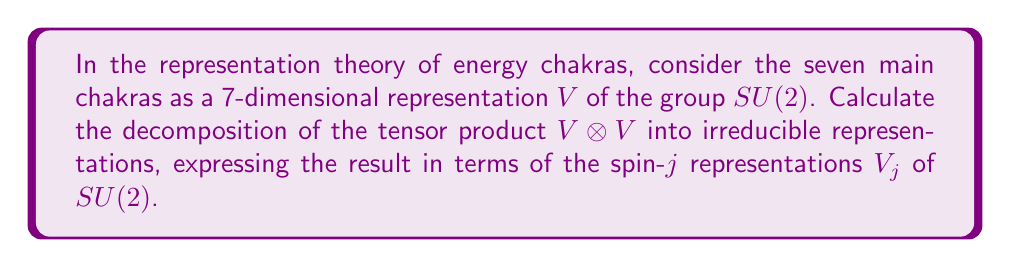Can you answer this question? To solve this problem, we'll follow these steps:

1) First, recall that the 7-dimensional representation $V$ of $SU(2)$ corresponds to the spin-3 representation $V_3$.

2) The general formula for decomposing the tensor product of two irreducible representations of $SU(2)$ is:

   $$V_j \otimes V_k \cong V_{|j-k|} \oplus V_{|j-k|+1} \oplus ... \oplus V_{j+k-1} \oplus V_{j+k}$$

3) In our case, $j = k = 3$, so we have:

   $$V_3 \otimes V_3 \cong V_{|3-3|} \oplus V_{|3-3|+1} \oplus ... \oplus V_{3+3-1} \oplus V_{3+3}$$

4) Simplifying:

   $$V_3 \otimes V_3 \cong V_0 \oplus V_1 \oplus V_2 \oplus V_3 \oplus V_4 \oplus V_5 \oplus V_6$$

5) Now, let's recall the dimensions of these representations:
   - $\dim V_j = 2j + 1$

6) Therefore, the dimensions of the components in our decomposition are:
   - $\dim V_0 = 1$
   - $\dim V_1 = 3$
   - $\dim V_2 = 5$
   - $\dim V_3 = 7$
   - $\dim V_4 = 9$
   - $\dim V_5 = 11$
   - $\dim V_6 = 13$

7) We can verify our decomposition by checking that the sum of these dimensions equals $\dim(V \otimes V) = 7^2 = 49$:

   $$1 + 3 + 5 + 7 + 9 + 11 + 13 = 49$$

Thus, our decomposition is correct.
Answer: $V \otimes V \cong V_0 \oplus V_1 \oplus V_2 \oplus V_3 \oplus V_4 \oplus V_5 \oplus V_6$ 